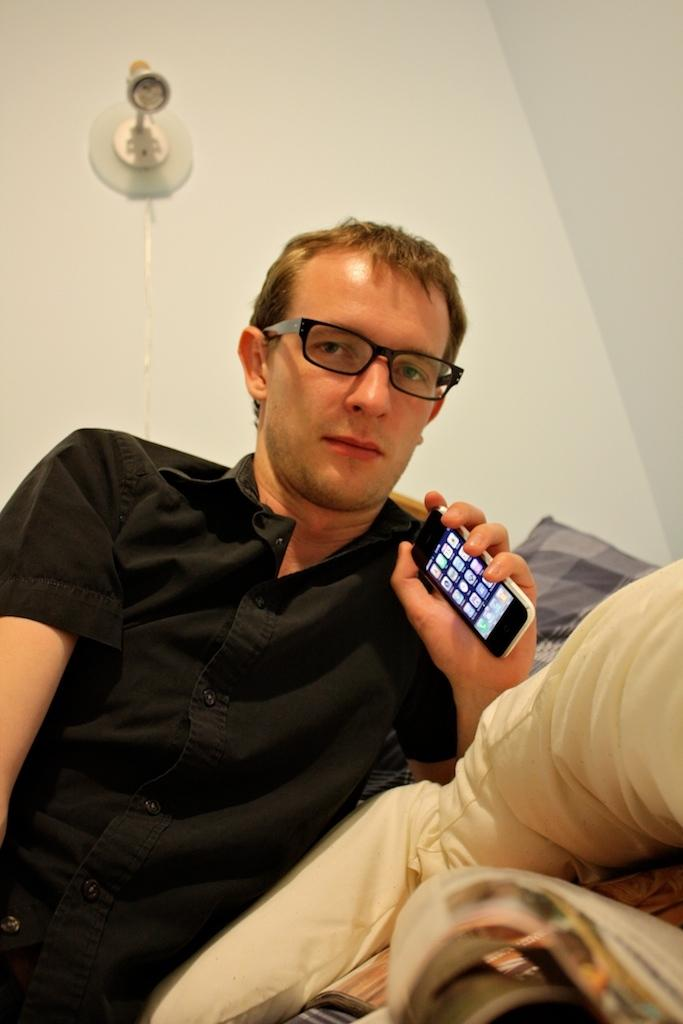What is the man in the image wearing? The man is wearing a black shirt. What accessory is the man wearing in the image? The man is wearing spectacles. What is the man holding in his hand in the image? The man is holding a mobile phone in his hand. What can be seen on the bed in the image? There is a pillow on a bed in the image. What is visible in the background of the image? There is a wall and a light in the background of the image. What type of boot is the man wearing in the image? The man is not wearing any boots in the image; he is wearing a black shirt and spectacles. 